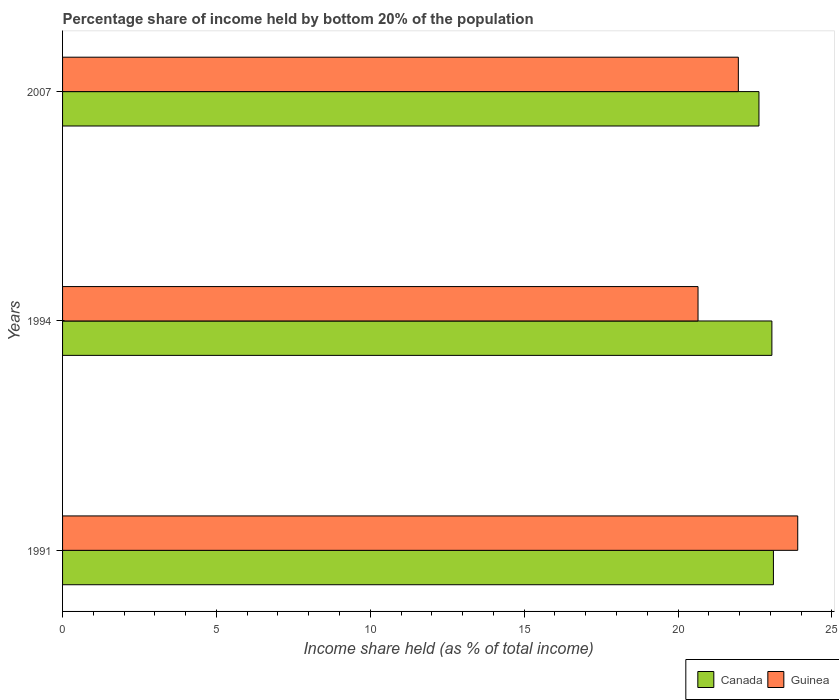Are the number of bars per tick equal to the number of legend labels?
Provide a succinct answer. Yes. How many bars are there on the 3rd tick from the top?
Offer a very short reply. 2. In how many cases, is the number of bars for a given year not equal to the number of legend labels?
Keep it short and to the point. 0. What is the share of income held by bottom 20% of the population in Guinea in 1991?
Ensure brevity in your answer.  23.89. Across all years, what is the maximum share of income held by bottom 20% of the population in Guinea?
Ensure brevity in your answer.  23.89. Across all years, what is the minimum share of income held by bottom 20% of the population in Guinea?
Offer a very short reply. 20.65. In which year was the share of income held by bottom 20% of the population in Canada maximum?
Provide a succinct answer. 1991. In which year was the share of income held by bottom 20% of the population in Guinea minimum?
Your answer should be compact. 1994. What is the total share of income held by bottom 20% of the population in Guinea in the graph?
Offer a terse response. 66.5. What is the difference between the share of income held by bottom 20% of the population in Guinea in 1994 and that in 2007?
Give a very brief answer. -1.31. What is the difference between the share of income held by bottom 20% of the population in Guinea in 1994 and the share of income held by bottom 20% of the population in Canada in 2007?
Make the answer very short. -1.98. What is the average share of income held by bottom 20% of the population in Canada per year?
Your answer should be very brief. 22.93. In the year 1991, what is the difference between the share of income held by bottom 20% of the population in Canada and share of income held by bottom 20% of the population in Guinea?
Provide a succinct answer. -0.79. In how many years, is the share of income held by bottom 20% of the population in Canada greater than 3 %?
Give a very brief answer. 3. What is the ratio of the share of income held by bottom 20% of the population in Canada in 1994 to that in 2007?
Offer a terse response. 1.02. Is the difference between the share of income held by bottom 20% of the population in Canada in 1991 and 1994 greater than the difference between the share of income held by bottom 20% of the population in Guinea in 1991 and 1994?
Your answer should be compact. No. What is the difference between the highest and the second highest share of income held by bottom 20% of the population in Canada?
Give a very brief answer. 0.05. What is the difference between the highest and the lowest share of income held by bottom 20% of the population in Canada?
Provide a short and direct response. 0.47. In how many years, is the share of income held by bottom 20% of the population in Canada greater than the average share of income held by bottom 20% of the population in Canada taken over all years?
Give a very brief answer. 2. What does the 2nd bar from the top in 1991 represents?
Provide a succinct answer. Canada. How many bars are there?
Offer a terse response. 6. Are all the bars in the graph horizontal?
Your answer should be very brief. Yes. How many years are there in the graph?
Ensure brevity in your answer.  3. What is the difference between two consecutive major ticks on the X-axis?
Offer a very short reply. 5. Does the graph contain any zero values?
Offer a terse response. No. Does the graph contain grids?
Ensure brevity in your answer.  No. Where does the legend appear in the graph?
Keep it short and to the point. Bottom right. How many legend labels are there?
Your response must be concise. 2. What is the title of the graph?
Your answer should be very brief. Percentage share of income held by bottom 20% of the population. Does "Ukraine" appear as one of the legend labels in the graph?
Offer a very short reply. No. What is the label or title of the X-axis?
Your response must be concise. Income share held (as % of total income). What is the label or title of the Y-axis?
Provide a short and direct response. Years. What is the Income share held (as % of total income) in Canada in 1991?
Your answer should be very brief. 23.1. What is the Income share held (as % of total income) of Guinea in 1991?
Offer a very short reply. 23.89. What is the Income share held (as % of total income) in Canada in 1994?
Offer a very short reply. 23.05. What is the Income share held (as % of total income) of Guinea in 1994?
Offer a terse response. 20.65. What is the Income share held (as % of total income) in Canada in 2007?
Your response must be concise. 22.63. What is the Income share held (as % of total income) of Guinea in 2007?
Keep it short and to the point. 21.96. Across all years, what is the maximum Income share held (as % of total income) of Canada?
Your answer should be compact. 23.1. Across all years, what is the maximum Income share held (as % of total income) in Guinea?
Make the answer very short. 23.89. Across all years, what is the minimum Income share held (as % of total income) of Canada?
Make the answer very short. 22.63. Across all years, what is the minimum Income share held (as % of total income) in Guinea?
Offer a very short reply. 20.65. What is the total Income share held (as % of total income) in Canada in the graph?
Give a very brief answer. 68.78. What is the total Income share held (as % of total income) of Guinea in the graph?
Your response must be concise. 66.5. What is the difference between the Income share held (as % of total income) of Canada in 1991 and that in 1994?
Make the answer very short. 0.05. What is the difference between the Income share held (as % of total income) in Guinea in 1991 and that in 1994?
Ensure brevity in your answer.  3.24. What is the difference between the Income share held (as % of total income) of Canada in 1991 and that in 2007?
Ensure brevity in your answer.  0.47. What is the difference between the Income share held (as % of total income) in Guinea in 1991 and that in 2007?
Give a very brief answer. 1.93. What is the difference between the Income share held (as % of total income) in Canada in 1994 and that in 2007?
Your response must be concise. 0.42. What is the difference between the Income share held (as % of total income) of Guinea in 1994 and that in 2007?
Your answer should be compact. -1.31. What is the difference between the Income share held (as % of total income) of Canada in 1991 and the Income share held (as % of total income) of Guinea in 1994?
Give a very brief answer. 2.45. What is the difference between the Income share held (as % of total income) of Canada in 1991 and the Income share held (as % of total income) of Guinea in 2007?
Offer a terse response. 1.14. What is the difference between the Income share held (as % of total income) of Canada in 1994 and the Income share held (as % of total income) of Guinea in 2007?
Your answer should be very brief. 1.09. What is the average Income share held (as % of total income) in Canada per year?
Give a very brief answer. 22.93. What is the average Income share held (as % of total income) in Guinea per year?
Your answer should be compact. 22.17. In the year 1991, what is the difference between the Income share held (as % of total income) in Canada and Income share held (as % of total income) in Guinea?
Provide a short and direct response. -0.79. In the year 1994, what is the difference between the Income share held (as % of total income) of Canada and Income share held (as % of total income) of Guinea?
Provide a short and direct response. 2.4. In the year 2007, what is the difference between the Income share held (as % of total income) of Canada and Income share held (as % of total income) of Guinea?
Give a very brief answer. 0.67. What is the ratio of the Income share held (as % of total income) of Guinea in 1991 to that in 1994?
Keep it short and to the point. 1.16. What is the ratio of the Income share held (as % of total income) of Canada in 1991 to that in 2007?
Make the answer very short. 1.02. What is the ratio of the Income share held (as % of total income) of Guinea in 1991 to that in 2007?
Your answer should be compact. 1.09. What is the ratio of the Income share held (as % of total income) of Canada in 1994 to that in 2007?
Your response must be concise. 1.02. What is the ratio of the Income share held (as % of total income) in Guinea in 1994 to that in 2007?
Offer a very short reply. 0.94. What is the difference between the highest and the second highest Income share held (as % of total income) in Guinea?
Your answer should be compact. 1.93. What is the difference between the highest and the lowest Income share held (as % of total income) in Canada?
Give a very brief answer. 0.47. What is the difference between the highest and the lowest Income share held (as % of total income) of Guinea?
Offer a terse response. 3.24. 